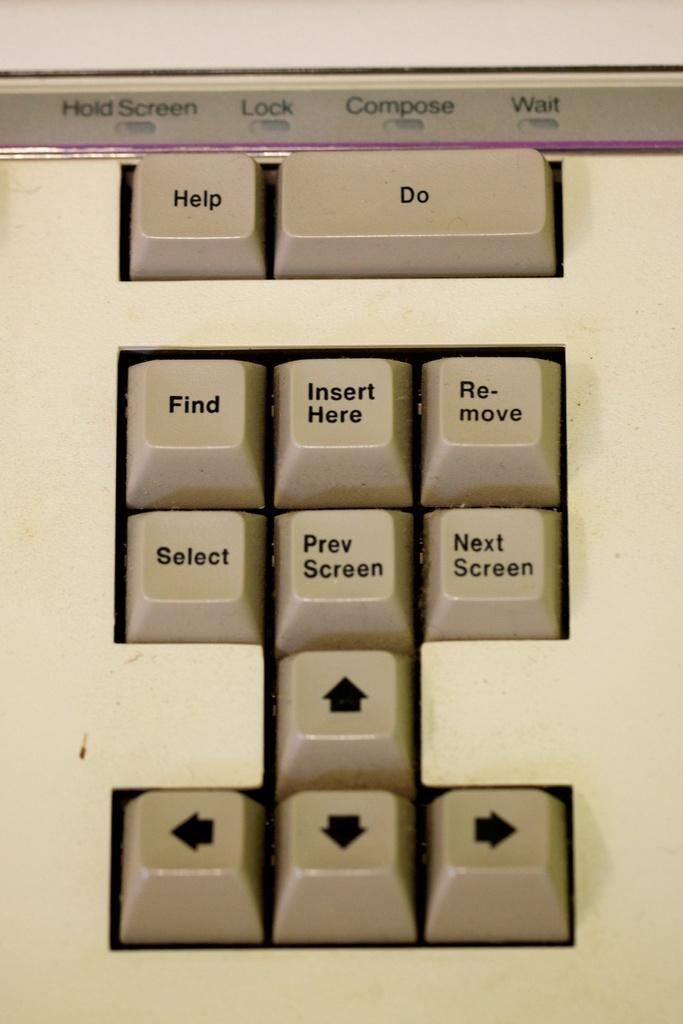<image>
Share a concise interpretation of the image provided. A group of keyboard buttons with the word Help written on one of them. 